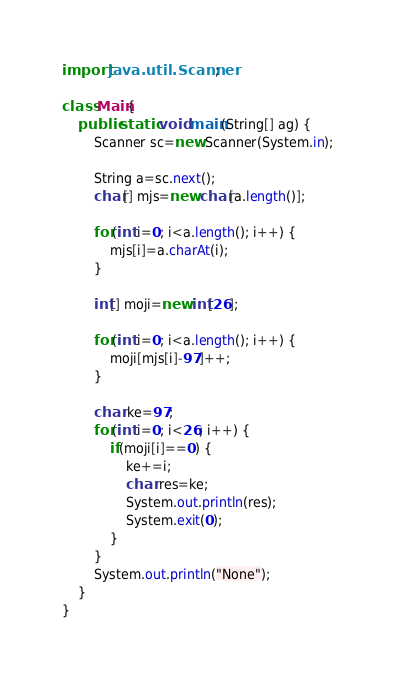Convert code to text. <code><loc_0><loc_0><loc_500><loc_500><_Java_>
import java.util.Scanner;

class Main{
	public static void main(String[] ag) {
		Scanner sc=new Scanner(System.in);

		String a=sc.next();
		char[] mjs=new char[a.length()];

		for(int i=0; i<a.length(); i++) {
			mjs[i]=a.charAt(i);
		}

		int[] moji=new int[26];

		for(int i=0; i<a.length(); i++) {
			moji[mjs[i]-97]++;
		}

		char ke=97;
		for(int i=0; i<26; i++) {
			if(moji[i]==0) {
				ke+=i;
				char res=ke;
				System.out.println(res);
				System.exit(0);
			}
		}
		System.out.println("None");
	}
}</code> 